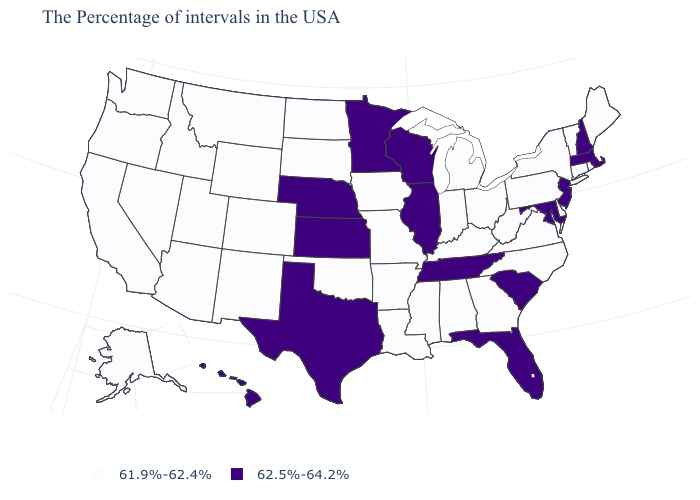What is the value of Delaware?
Give a very brief answer. 61.9%-62.4%. Is the legend a continuous bar?
Quick response, please. No. Does Illinois have a higher value than New Hampshire?
Answer briefly. No. Name the states that have a value in the range 61.9%-62.4%?
Quick response, please. Maine, Rhode Island, Vermont, Connecticut, New York, Delaware, Pennsylvania, Virginia, North Carolina, West Virginia, Ohio, Georgia, Michigan, Kentucky, Indiana, Alabama, Mississippi, Louisiana, Missouri, Arkansas, Iowa, Oklahoma, South Dakota, North Dakota, Wyoming, Colorado, New Mexico, Utah, Montana, Arizona, Idaho, Nevada, California, Washington, Oregon, Alaska. What is the value of California?
Concise answer only. 61.9%-62.4%. Does Indiana have the lowest value in the MidWest?
Write a very short answer. Yes. Which states have the highest value in the USA?
Concise answer only. Massachusetts, New Hampshire, New Jersey, Maryland, South Carolina, Florida, Tennessee, Wisconsin, Illinois, Minnesota, Kansas, Nebraska, Texas, Hawaii. What is the lowest value in the West?
Write a very short answer. 61.9%-62.4%. Which states hav the highest value in the Northeast?
Keep it brief. Massachusetts, New Hampshire, New Jersey. Which states have the lowest value in the South?
Answer briefly. Delaware, Virginia, North Carolina, West Virginia, Georgia, Kentucky, Alabama, Mississippi, Louisiana, Arkansas, Oklahoma. What is the lowest value in states that border New Mexico?
Give a very brief answer. 61.9%-62.4%. Which states hav the highest value in the Northeast?
Concise answer only. Massachusetts, New Hampshire, New Jersey. What is the highest value in the MidWest ?
Quick response, please. 62.5%-64.2%. Which states have the lowest value in the USA?
Give a very brief answer. Maine, Rhode Island, Vermont, Connecticut, New York, Delaware, Pennsylvania, Virginia, North Carolina, West Virginia, Ohio, Georgia, Michigan, Kentucky, Indiana, Alabama, Mississippi, Louisiana, Missouri, Arkansas, Iowa, Oklahoma, South Dakota, North Dakota, Wyoming, Colorado, New Mexico, Utah, Montana, Arizona, Idaho, Nevada, California, Washington, Oregon, Alaska. 